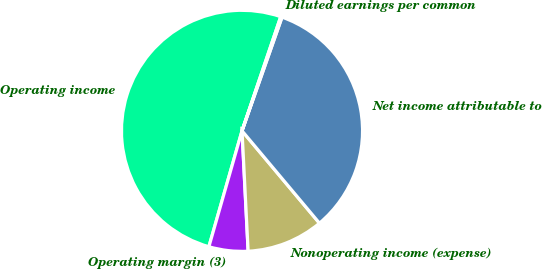Convert chart. <chart><loc_0><loc_0><loc_500><loc_500><pie_chart><fcel>Operating income<fcel>Operating margin (3)<fcel>Nonoperating income (expense)<fcel>Net income attributable to<fcel>Diluted earnings per common<nl><fcel>50.77%<fcel>5.24%<fcel>10.3%<fcel>33.51%<fcel>0.18%<nl></chart> 